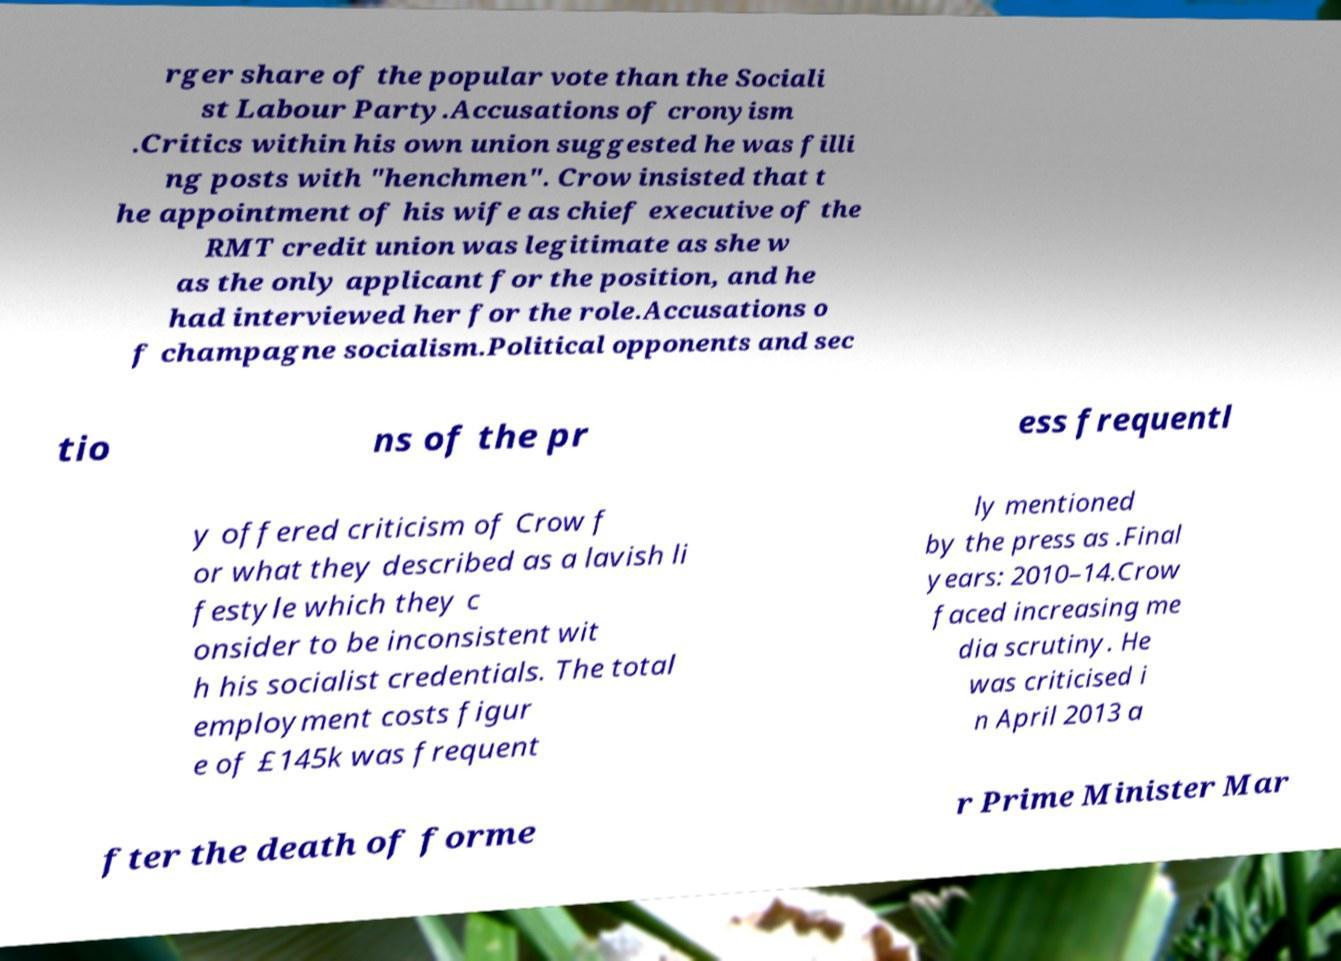Please identify and transcribe the text found in this image. rger share of the popular vote than the Sociali st Labour Party.Accusations of cronyism .Critics within his own union suggested he was filli ng posts with "henchmen". Crow insisted that t he appointment of his wife as chief executive of the RMT credit union was legitimate as she w as the only applicant for the position, and he had interviewed her for the role.Accusations o f champagne socialism.Political opponents and sec tio ns of the pr ess frequentl y offered criticism of Crow f or what they described as a lavish li festyle which they c onsider to be inconsistent wit h his socialist credentials. The total employment costs figur e of £145k was frequent ly mentioned by the press as .Final years: 2010–14.Crow faced increasing me dia scrutiny. He was criticised i n April 2013 a fter the death of forme r Prime Minister Mar 